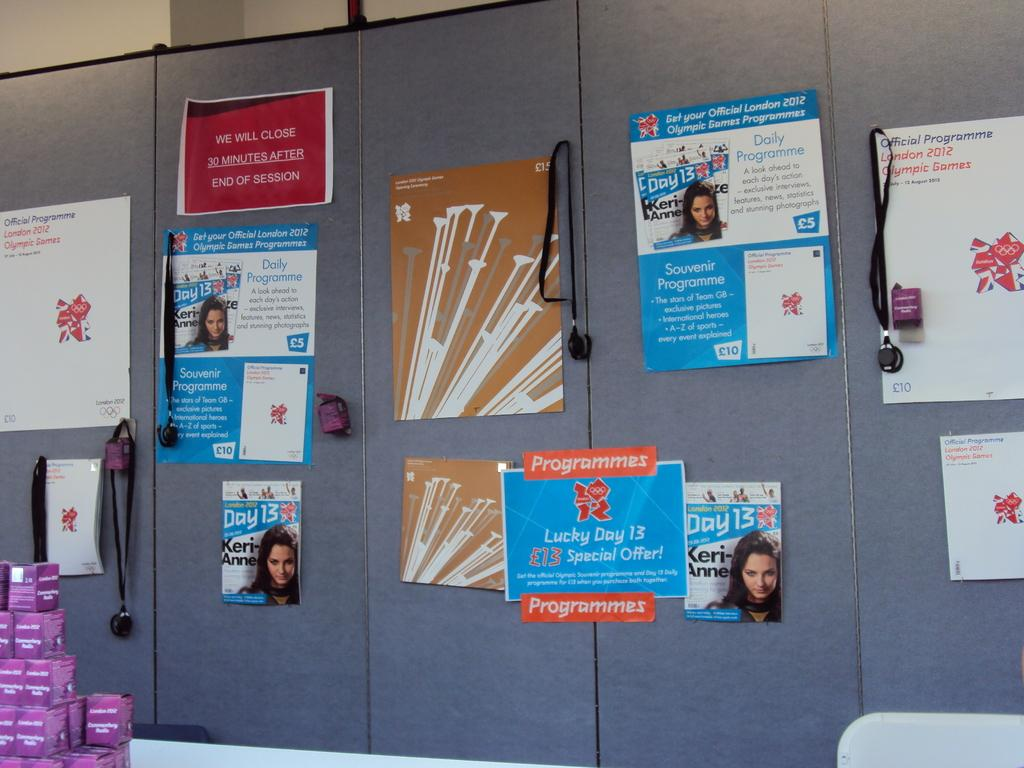<image>
Write a terse but informative summary of the picture. Cabinets with pictures from magazines with Keri Anne. 